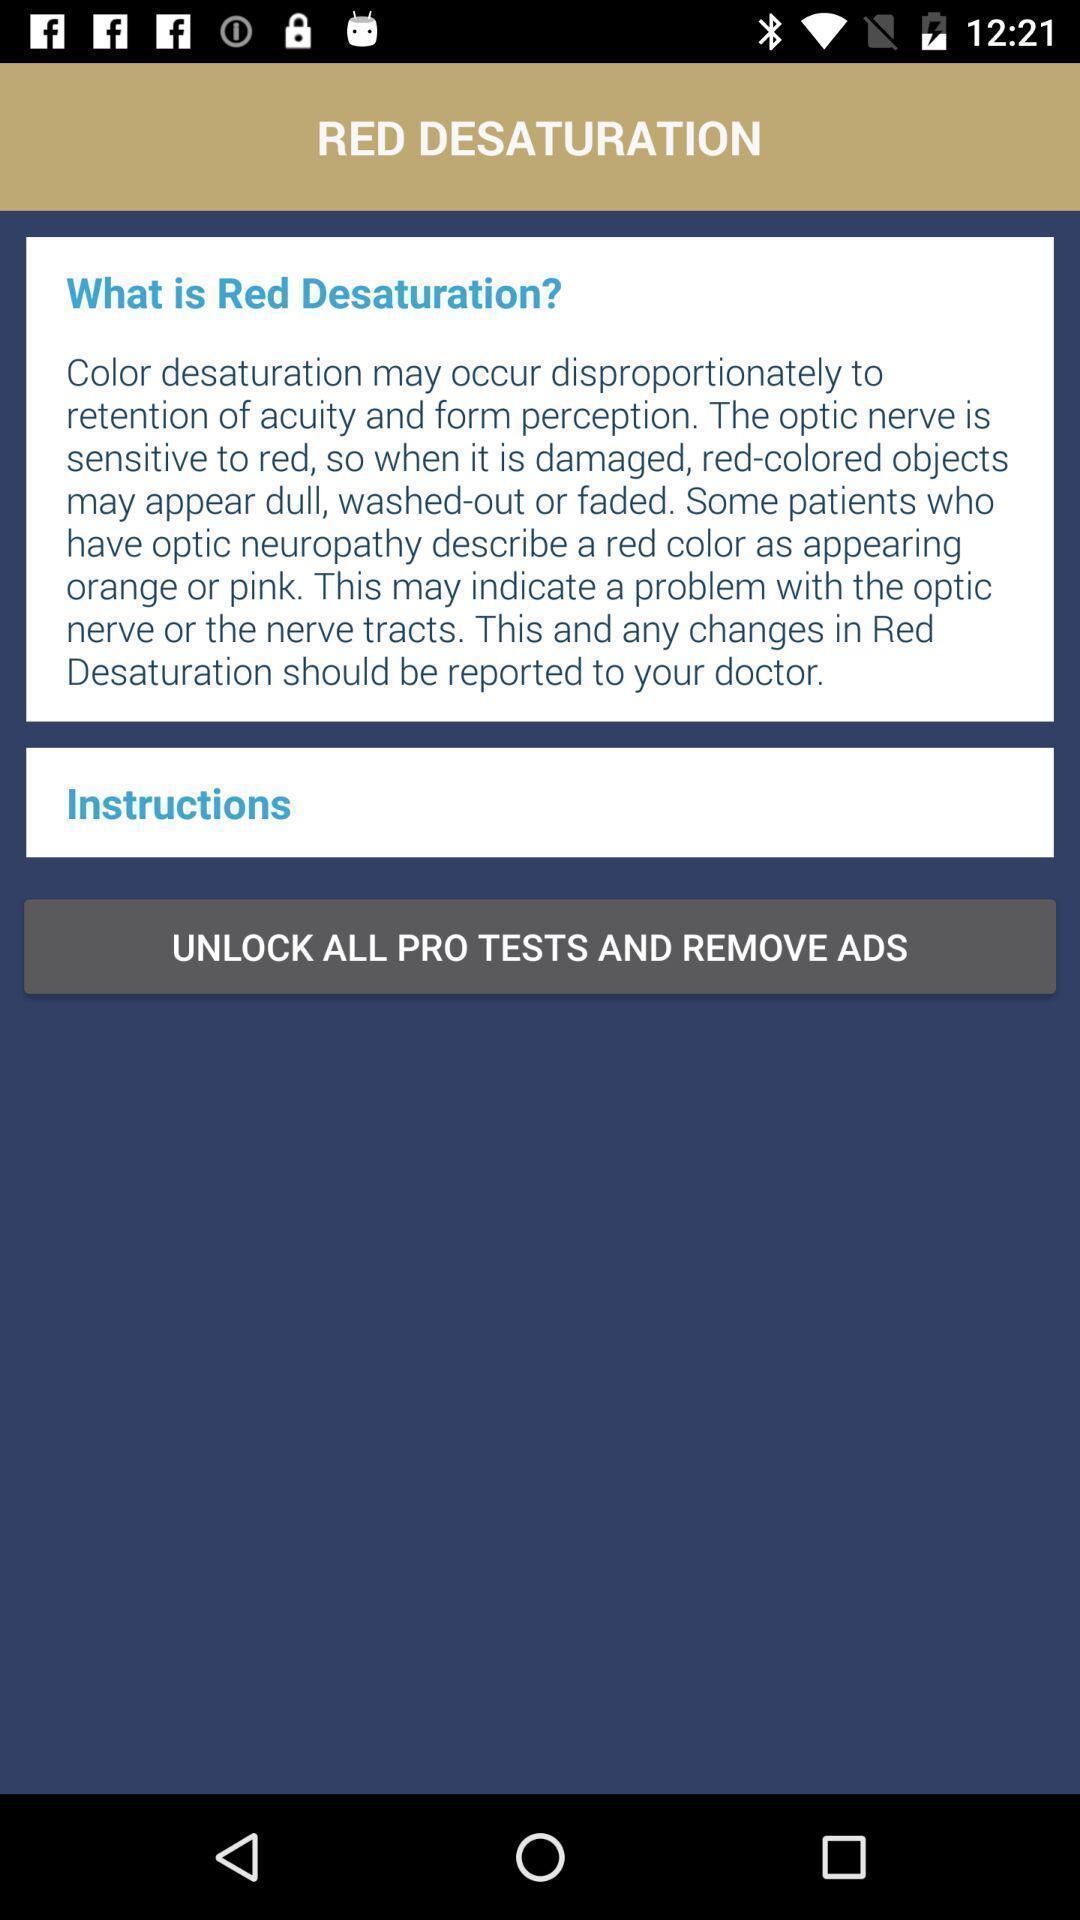Describe the content in this image. Screen showing topic content and details in an learning app. 